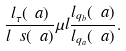Convert formula to latex. <formula><loc_0><loc_0><loc_500><loc_500>\frac { l _ { \tau } ( \ a ) } { l _ { \ } s ( \ a ) } \mu l \frac { l _ { q _ { b } } ( \ a ) } { l _ { q _ { a } } ( \ a ) } .</formula> 